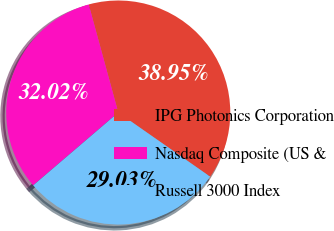Convert chart to OTSL. <chart><loc_0><loc_0><loc_500><loc_500><pie_chart><fcel>IPG Photonics Corporation<fcel>Nasdaq Composite (US &<fcel>Russell 3000 Index<nl><fcel>38.95%<fcel>32.02%<fcel>29.03%<nl></chart> 